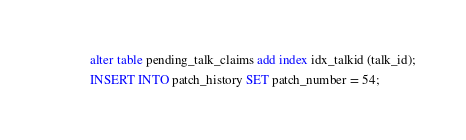<code> <loc_0><loc_0><loc_500><loc_500><_SQL_>alter table pending_talk_claims add index idx_talkid (talk_id);
INSERT INTO patch_history SET patch_number = 54;

</code> 